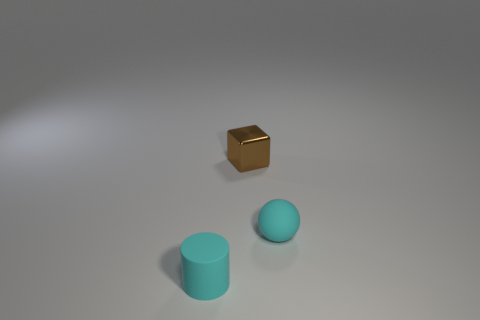What is the color of the thing that is behind the cylinder and left of the ball?
Give a very brief answer. Brown. Is the size of the cyan matte thing that is on the left side of the tiny shiny cube the same as the thing behind the cyan matte ball?
Your response must be concise. Yes. What number of objects are either matte things that are on the right side of the small cylinder or purple metallic things?
Ensure brevity in your answer.  1. What is the small ball made of?
Your answer should be compact. Rubber. Does the brown thing have the same size as the cyan matte sphere?
Ensure brevity in your answer.  Yes. How many balls are either tiny cyan matte objects or blue things?
Ensure brevity in your answer.  1. There is a small rubber thing right of the cyan thing that is in front of the tiny rubber sphere; what color is it?
Give a very brief answer. Cyan. Are there fewer brown shiny objects that are behind the tiny rubber cylinder than small rubber balls that are on the left side of the tiny cyan sphere?
Provide a short and direct response. No. There is a brown metal cube; is it the same size as the cyan object that is to the right of the tiny cyan rubber cylinder?
Provide a succinct answer. Yes. There is a object that is behind the cyan cylinder and to the left of the small sphere; what shape is it?
Offer a very short reply. Cube. 